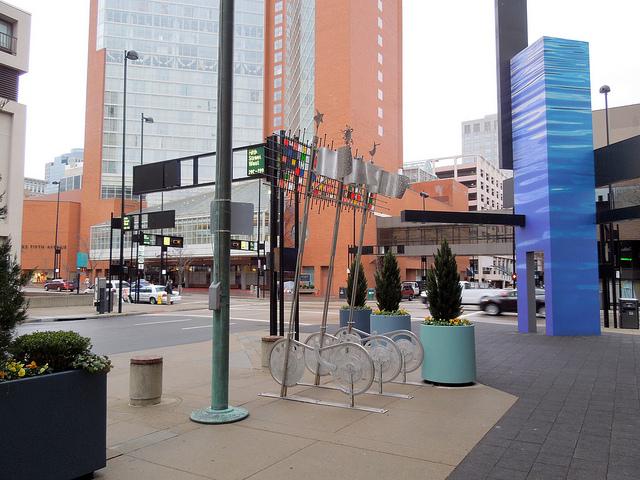Are there potted trees?
Answer briefly. Yes. What does the barrel indicate?
Short answer required. Planter. What is the blue object?
Quick response, please. Art. Where is the doorway?
Be succinct. In blue column. What  do the three white structures look like?
Keep it brief. Bicycles. Why might a person without a home to sleep in tonight be very interested in this image?
Give a very brief answer. Sky is clear. Is this a busy street?
Write a very short answer. Yes. 